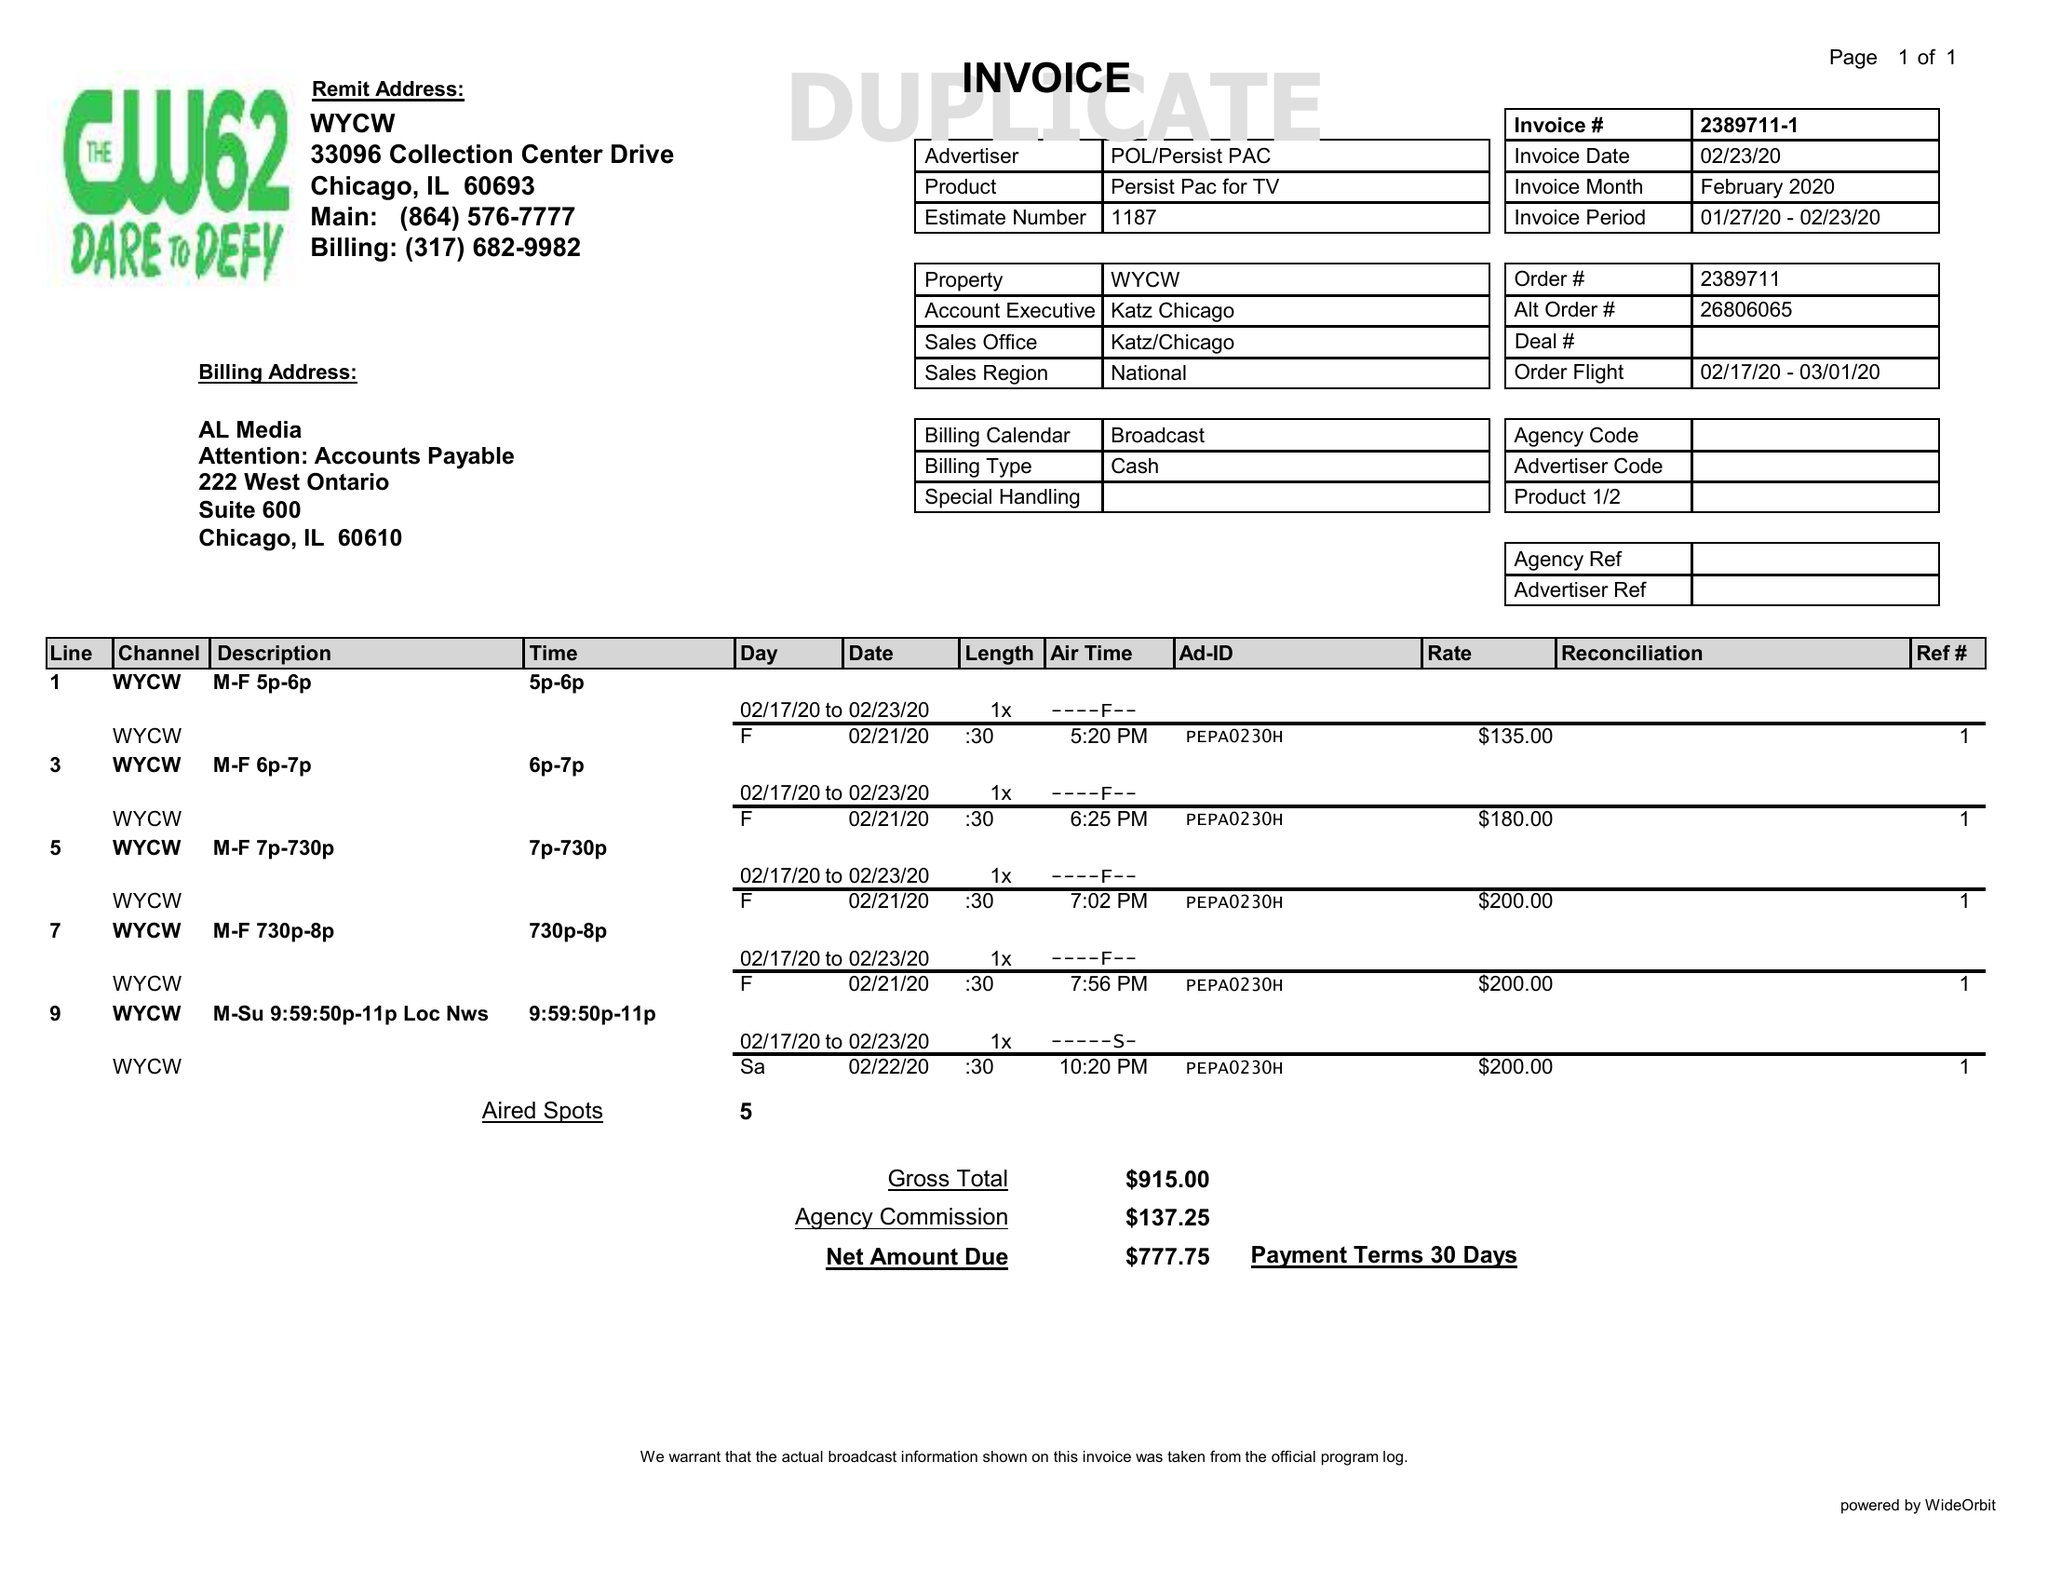What is the value for the flight_to?
Answer the question using a single word or phrase. 03/01/20 